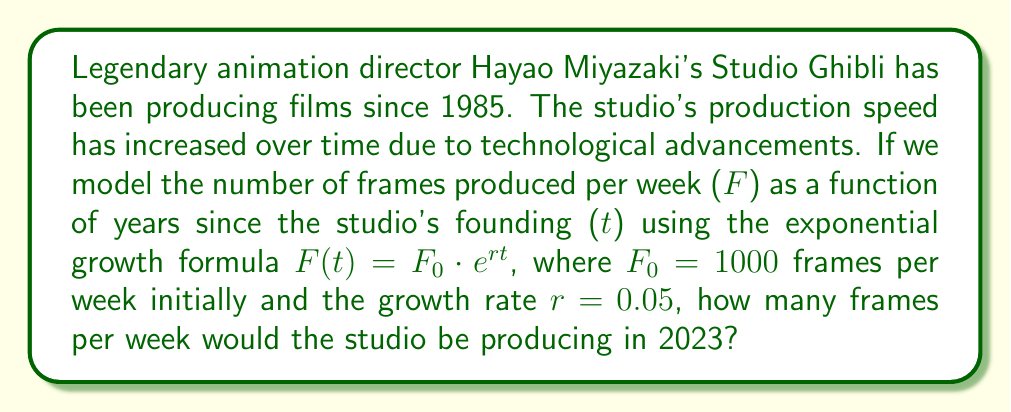Give your solution to this math problem. To solve this problem, we need to use the exponential growth formula:

$F(t) = F_0 \cdot e^{rt}$

Where:
$F(t)$ is the number of frames produced per week after $t$ years
$F_0 = 1000$ frames per week (initial production speed)
$r = 0.05$ (growth rate)
$t$ = number of years since the studio's founding

First, we need to calculate how many years have passed since Studio Ghibli's founding in 1985 to 2023:

$t = 2023 - 1985 = 38$ years

Now we can plug these values into our formula:

$F(38) = 1000 \cdot e^{0.05 \cdot 38}$

Using a calculator or computer to evaluate this expression:

$F(38) = 1000 \cdot e^{1.9}$
$F(38) = 1000 \cdot 6.6858...$
$F(38) = 6685.8...$ frames per week

Rounding to the nearest whole number, as we can't produce partial frames:

$F(38) \approx 6686$ frames per week
Answer: In 2023, Studio Ghibli would be producing approximately 6686 frames per week according to this model. 